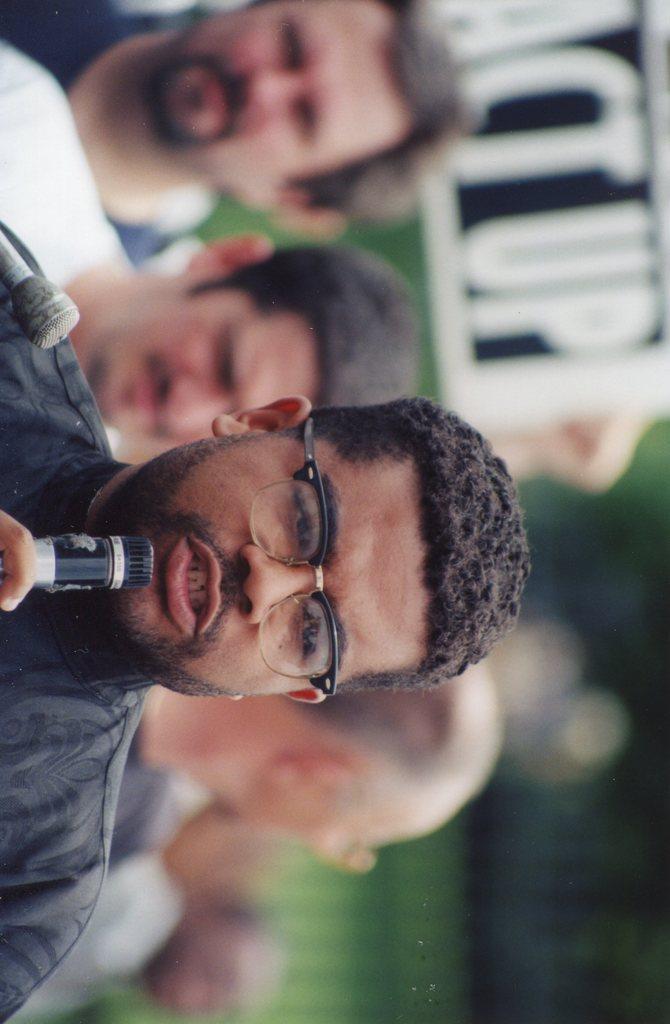Can you describe this image briefly? In this image we can see a man wearing the glasses and holding the mike. In the background we can see the people and also the board. 